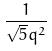<formula> <loc_0><loc_0><loc_500><loc_500>\frac { 1 } { \sqrt { 5 } q ^ { 2 } }</formula> 